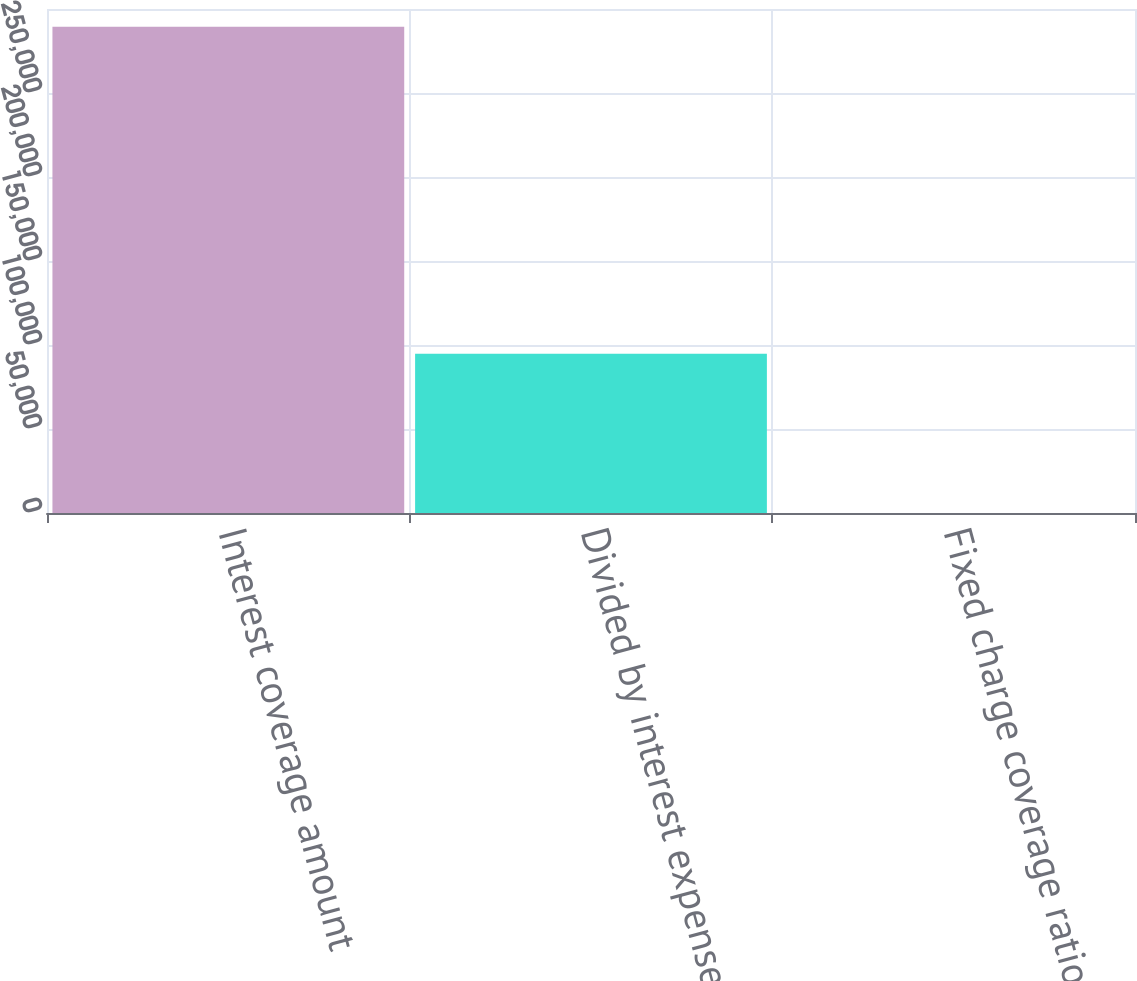<chart> <loc_0><loc_0><loc_500><loc_500><bar_chart><fcel>Interest coverage amount<fcel>Divided by interest expense<fcel>Fixed charge coverage ratio<nl><fcel>289413<fcel>94785<fcel>3.1<nl></chart> 